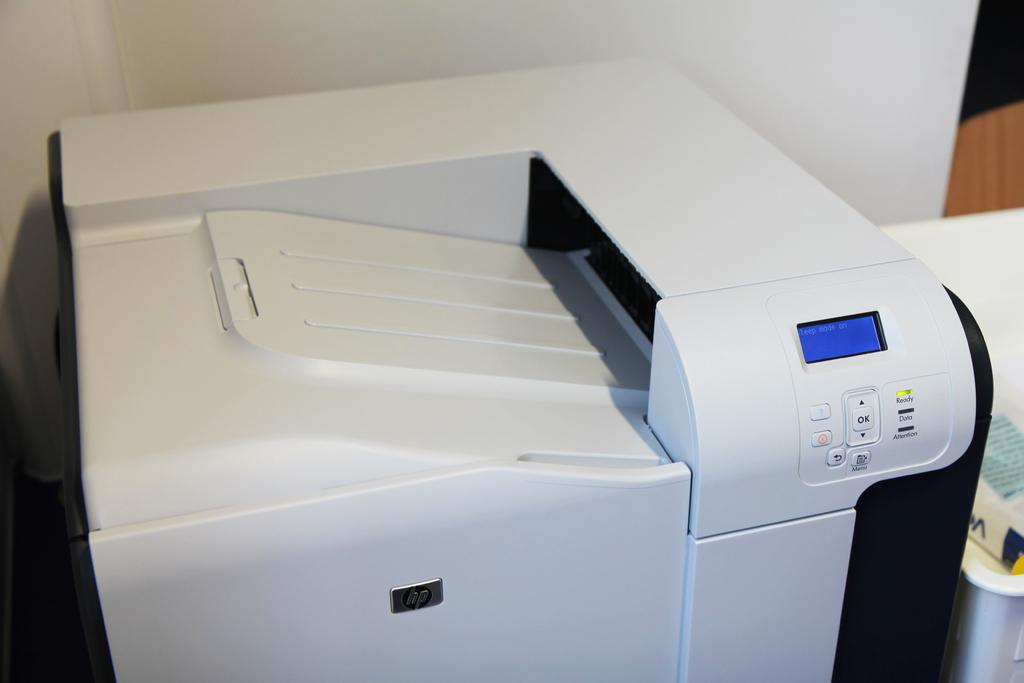<image>
Describe the image concisely. The printer displays states that sleep mode is on. 